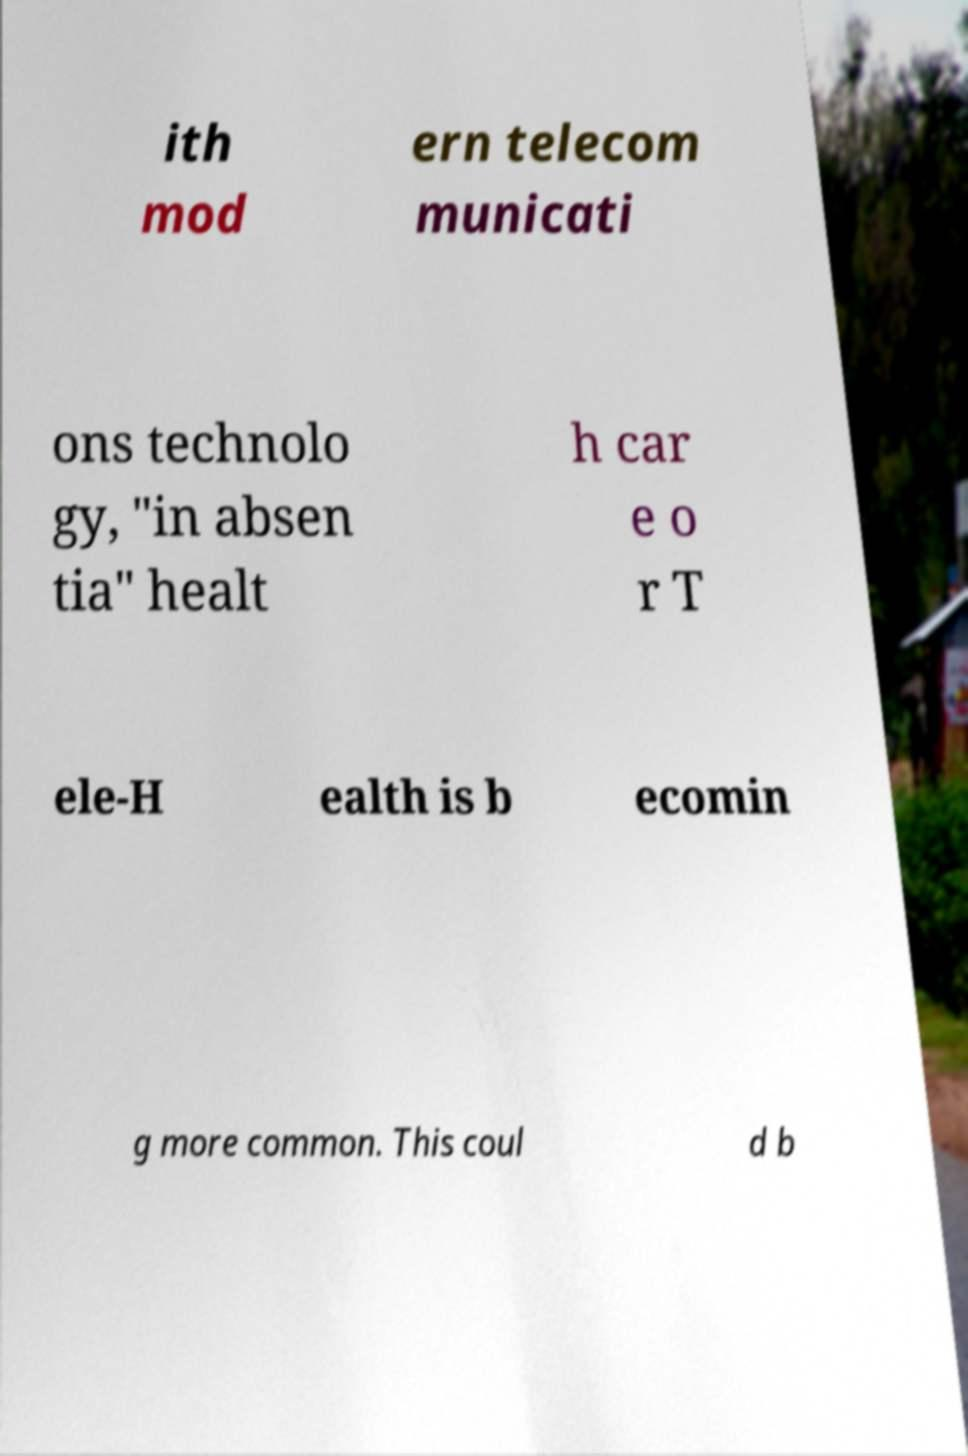Could you assist in decoding the text presented in this image and type it out clearly? ith mod ern telecom municati ons technolo gy, "in absen tia" healt h car e o r T ele-H ealth is b ecomin g more common. This coul d b 